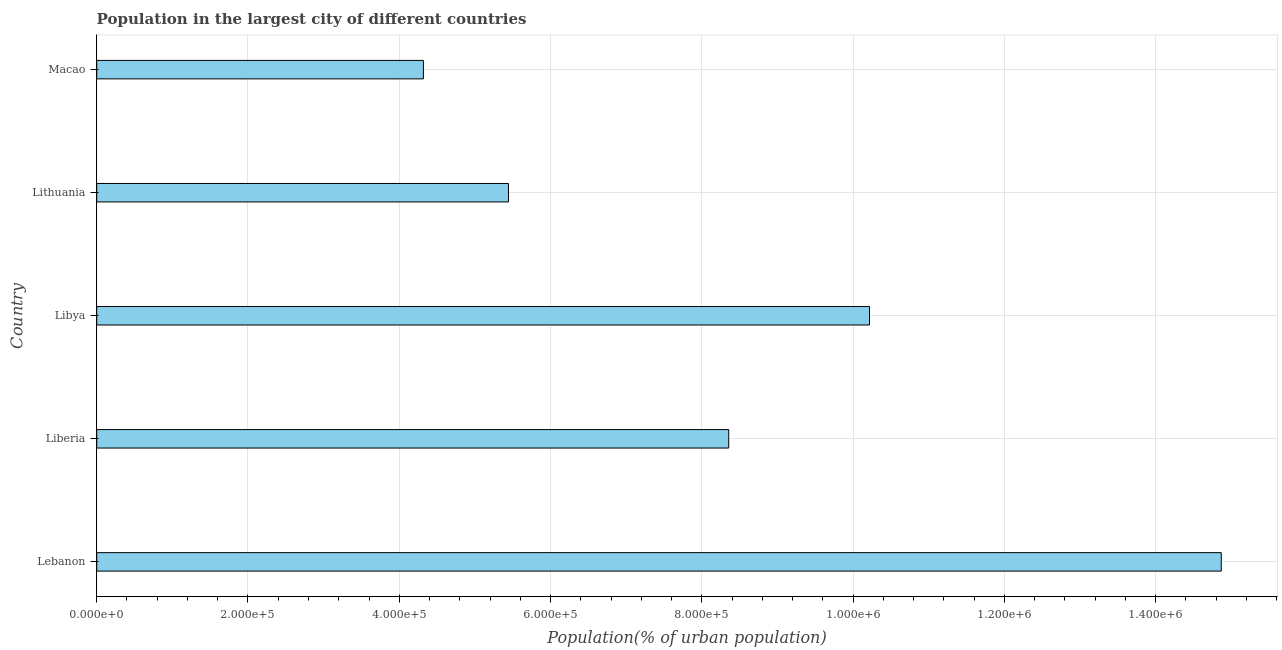Does the graph contain grids?
Offer a terse response. Yes. What is the title of the graph?
Your answer should be very brief. Population in the largest city of different countries. What is the label or title of the X-axis?
Your response must be concise. Population(% of urban population). What is the label or title of the Y-axis?
Make the answer very short. Country. What is the population in largest city in Macao?
Your response must be concise. 4.32e+05. Across all countries, what is the maximum population in largest city?
Offer a terse response. 1.49e+06. Across all countries, what is the minimum population in largest city?
Provide a short and direct response. 4.32e+05. In which country was the population in largest city maximum?
Make the answer very short. Lebanon. In which country was the population in largest city minimum?
Provide a succinct answer. Macao. What is the sum of the population in largest city?
Your answer should be very brief. 4.32e+06. What is the difference between the population in largest city in Lithuania and Macao?
Your answer should be compact. 1.12e+05. What is the average population in largest city per country?
Give a very brief answer. 8.64e+05. What is the median population in largest city?
Your answer should be very brief. 8.36e+05. What is the ratio of the population in largest city in Lithuania to that in Macao?
Offer a terse response. 1.26. Is the population in largest city in Liberia less than that in Libya?
Your answer should be very brief. Yes. Is the difference between the population in largest city in Liberia and Lithuania greater than the difference between any two countries?
Offer a terse response. No. What is the difference between the highest and the second highest population in largest city?
Make the answer very short. 4.65e+05. What is the difference between the highest and the lowest population in largest city?
Offer a terse response. 1.05e+06. Are the values on the major ticks of X-axis written in scientific E-notation?
Your answer should be compact. Yes. What is the Population(% of urban population) in Lebanon?
Make the answer very short. 1.49e+06. What is the Population(% of urban population) of Liberia?
Offer a terse response. 8.36e+05. What is the Population(% of urban population) in Libya?
Ensure brevity in your answer.  1.02e+06. What is the Population(% of urban population) of Lithuania?
Ensure brevity in your answer.  5.44e+05. What is the Population(% of urban population) in Macao?
Your response must be concise. 4.32e+05. What is the difference between the Population(% of urban population) in Lebanon and Liberia?
Your response must be concise. 6.51e+05. What is the difference between the Population(% of urban population) in Lebanon and Libya?
Keep it short and to the point. 4.65e+05. What is the difference between the Population(% of urban population) in Lebanon and Lithuania?
Your answer should be very brief. 9.42e+05. What is the difference between the Population(% of urban population) in Lebanon and Macao?
Make the answer very short. 1.05e+06. What is the difference between the Population(% of urban population) in Liberia and Libya?
Give a very brief answer. -1.86e+05. What is the difference between the Population(% of urban population) in Liberia and Lithuania?
Keep it short and to the point. 2.91e+05. What is the difference between the Population(% of urban population) in Liberia and Macao?
Provide a short and direct response. 4.04e+05. What is the difference between the Population(% of urban population) in Libya and Lithuania?
Provide a short and direct response. 4.77e+05. What is the difference between the Population(% of urban population) in Libya and Macao?
Offer a terse response. 5.90e+05. What is the difference between the Population(% of urban population) in Lithuania and Macao?
Offer a terse response. 1.12e+05. What is the ratio of the Population(% of urban population) in Lebanon to that in Liberia?
Make the answer very short. 1.78. What is the ratio of the Population(% of urban population) in Lebanon to that in Libya?
Offer a very short reply. 1.46. What is the ratio of the Population(% of urban population) in Lebanon to that in Lithuania?
Your response must be concise. 2.73. What is the ratio of the Population(% of urban population) in Lebanon to that in Macao?
Your response must be concise. 3.44. What is the ratio of the Population(% of urban population) in Liberia to that in Libya?
Offer a terse response. 0.82. What is the ratio of the Population(% of urban population) in Liberia to that in Lithuania?
Give a very brief answer. 1.53. What is the ratio of the Population(% of urban population) in Liberia to that in Macao?
Make the answer very short. 1.94. What is the ratio of the Population(% of urban population) in Libya to that in Lithuania?
Offer a terse response. 1.88. What is the ratio of the Population(% of urban population) in Libya to that in Macao?
Offer a terse response. 2.37. What is the ratio of the Population(% of urban population) in Lithuania to that in Macao?
Ensure brevity in your answer.  1.26. 